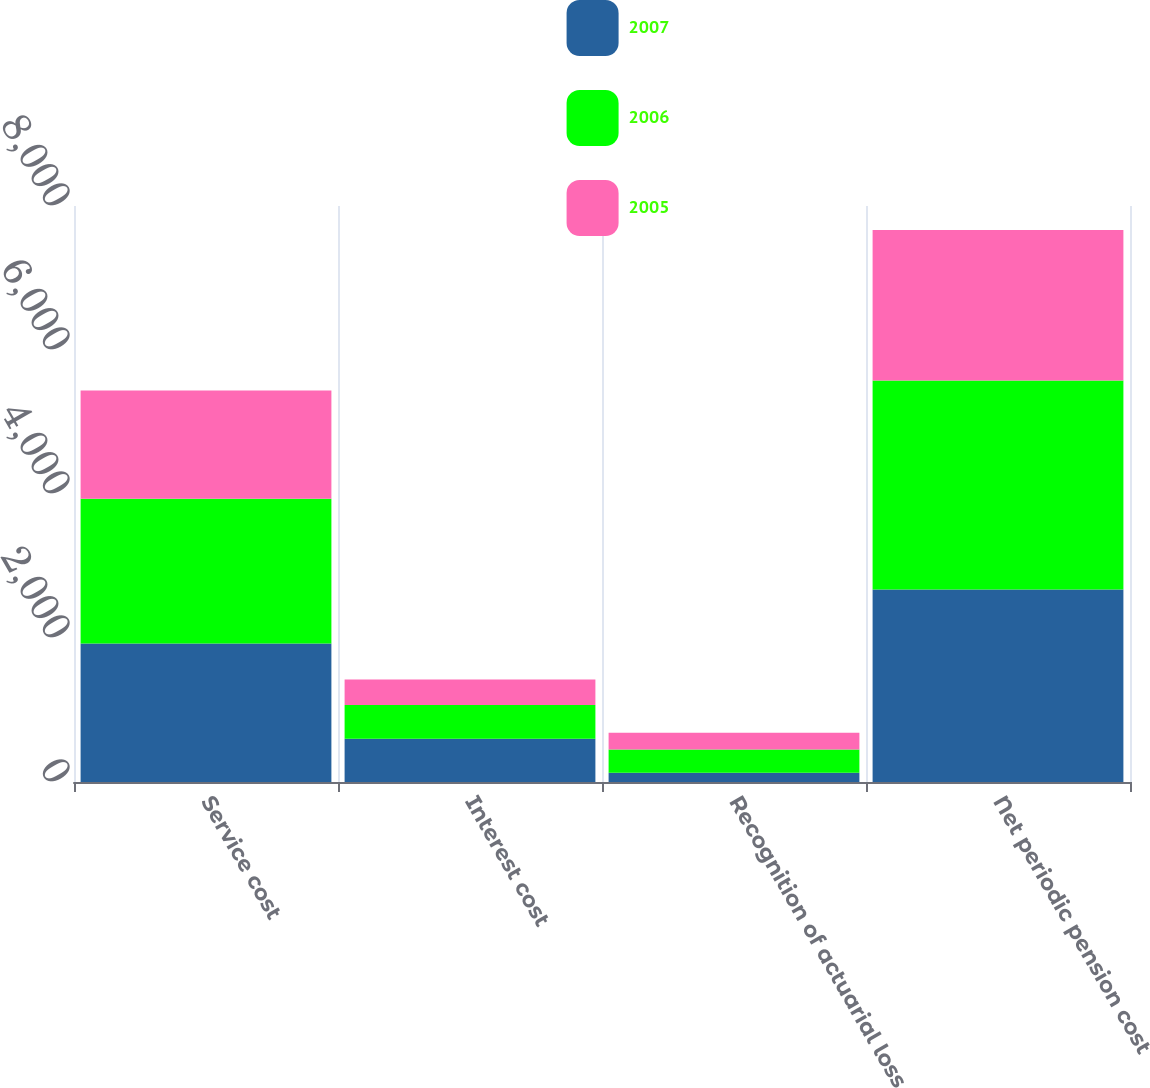Convert chart to OTSL. <chart><loc_0><loc_0><loc_500><loc_500><stacked_bar_chart><ecel><fcel>Service cost<fcel>Interest cost<fcel>Recognition of actuarial loss<fcel>Net periodic pension cost<nl><fcel>2007<fcel>1922<fcel>599<fcel>129<fcel>2674<nl><fcel>2006<fcel>2013<fcel>471<fcel>321<fcel>2903<nl><fcel>2005<fcel>1502<fcel>353<fcel>235<fcel>2090<nl></chart> 